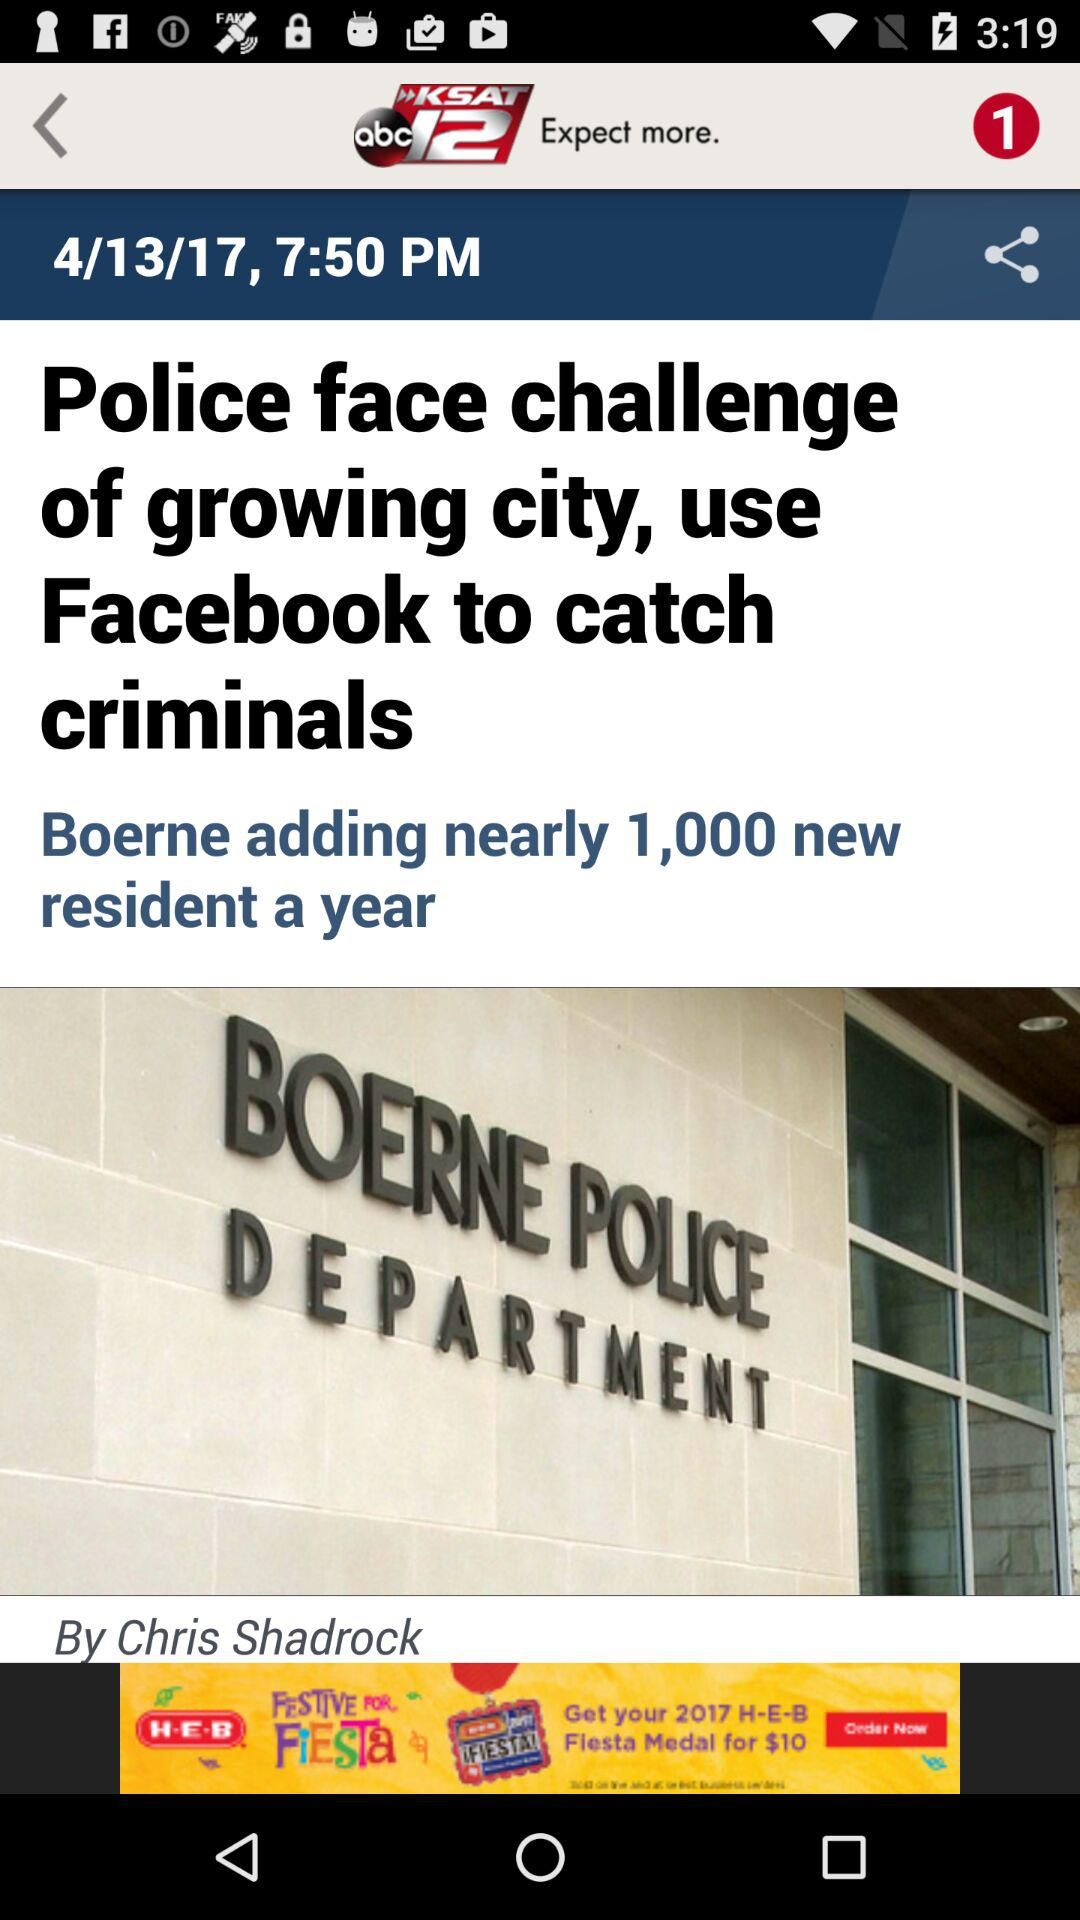When was the article published? The article was published on April 13, 2017 at 7:50 PM. 